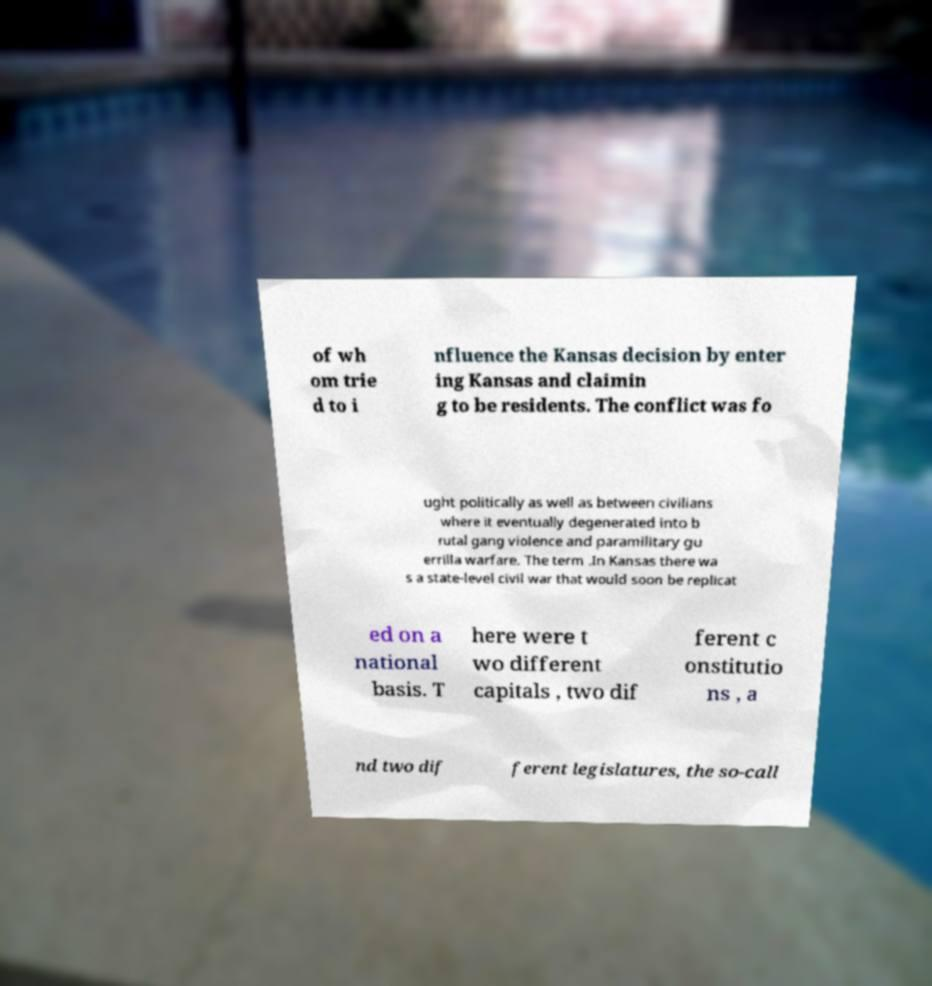There's text embedded in this image that I need extracted. Can you transcribe it verbatim? of wh om trie d to i nfluence the Kansas decision by enter ing Kansas and claimin g to be residents. The conflict was fo ught politically as well as between civilians where it eventually degenerated into b rutal gang violence and paramilitary gu errilla warfare. The term .In Kansas there wa s a state-level civil war that would soon be replicat ed on a national basis. T here were t wo different capitals , two dif ferent c onstitutio ns , a nd two dif ferent legislatures, the so-call 